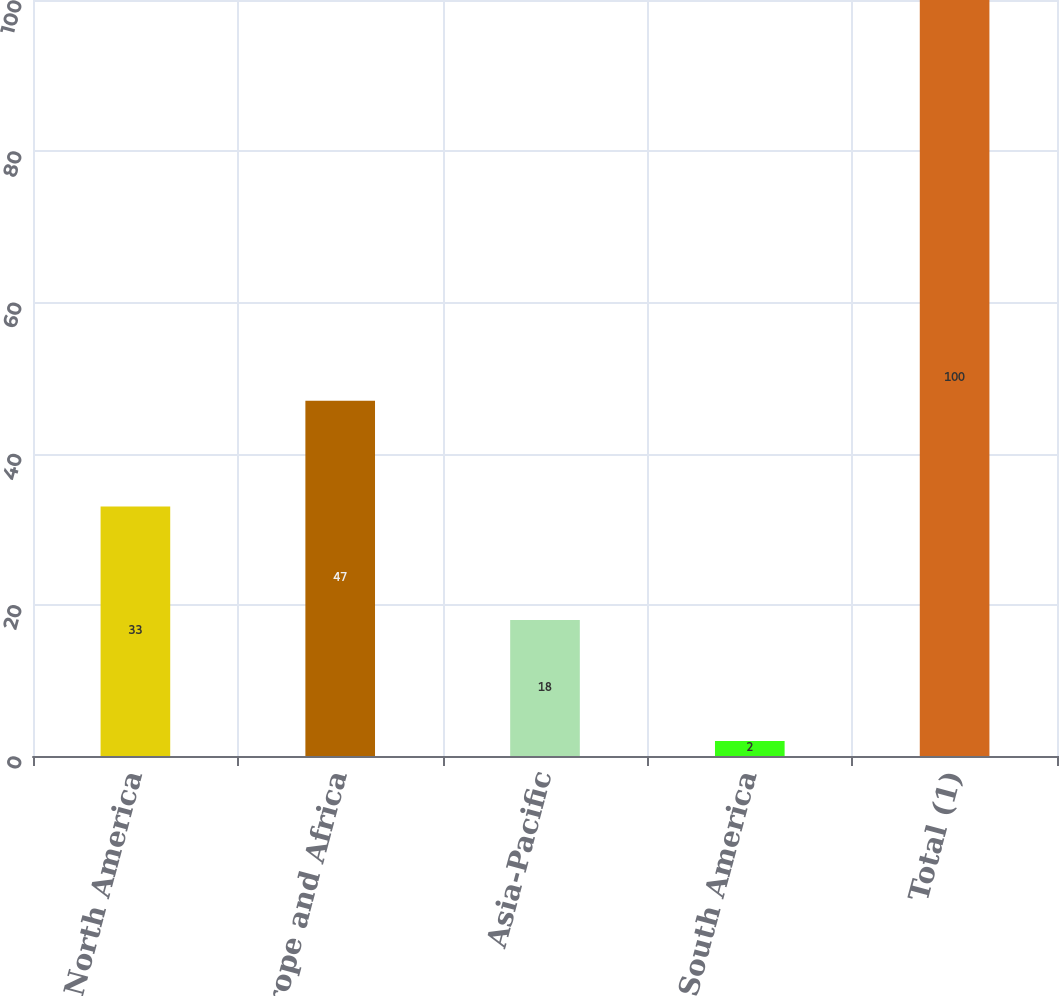Convert chart. <chart><loc_0><loc_0><loc_500><loc_500><bar_chart><fcel>North America<fcel>Europe and Africa<fcel>Asia-Pacific<fcel>South America<fcel>Total (1)<nl><fcel>33<fcel>47<fcel>18<fcel>2<fcel>100<nl></chart> 